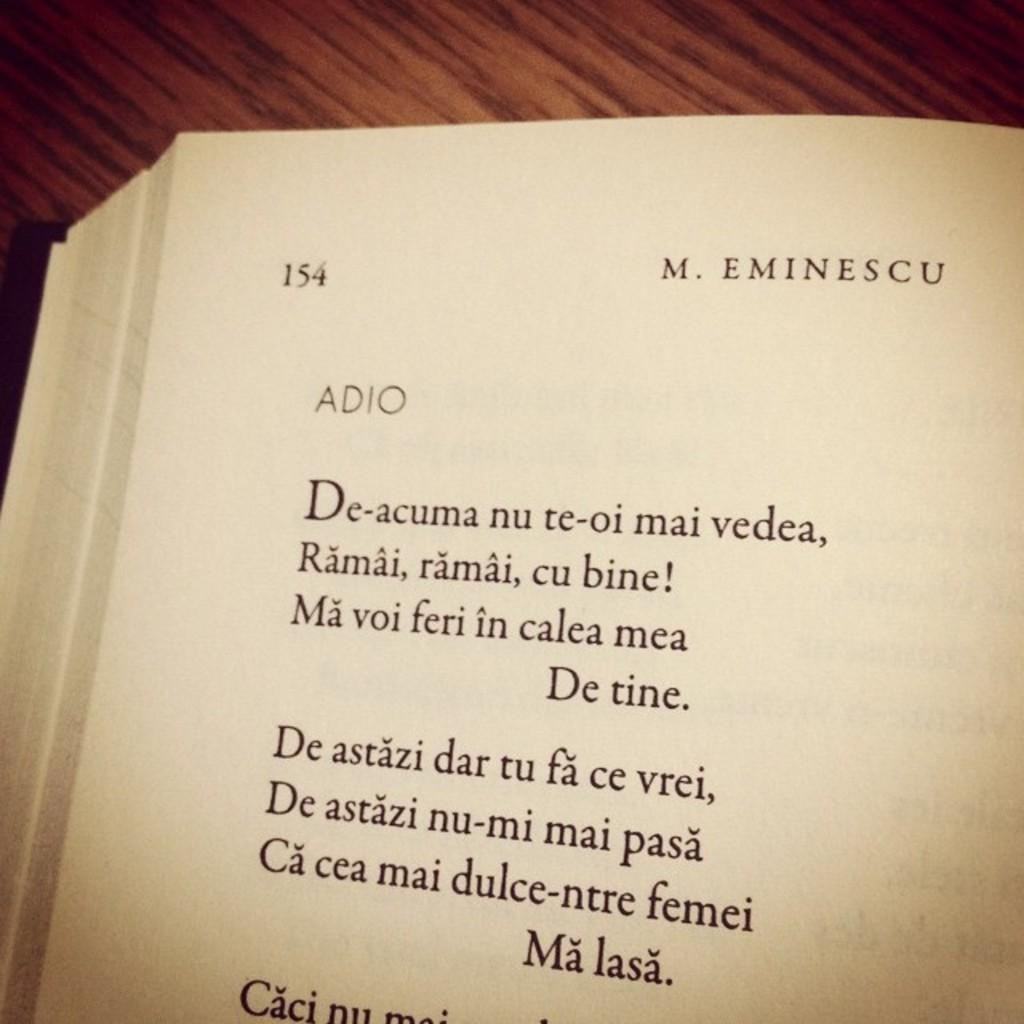<image>
Give a short and clear explanation of the subsequent image. A page of an open book that says M. Eminescu aat the top of the page and showing page 154. 